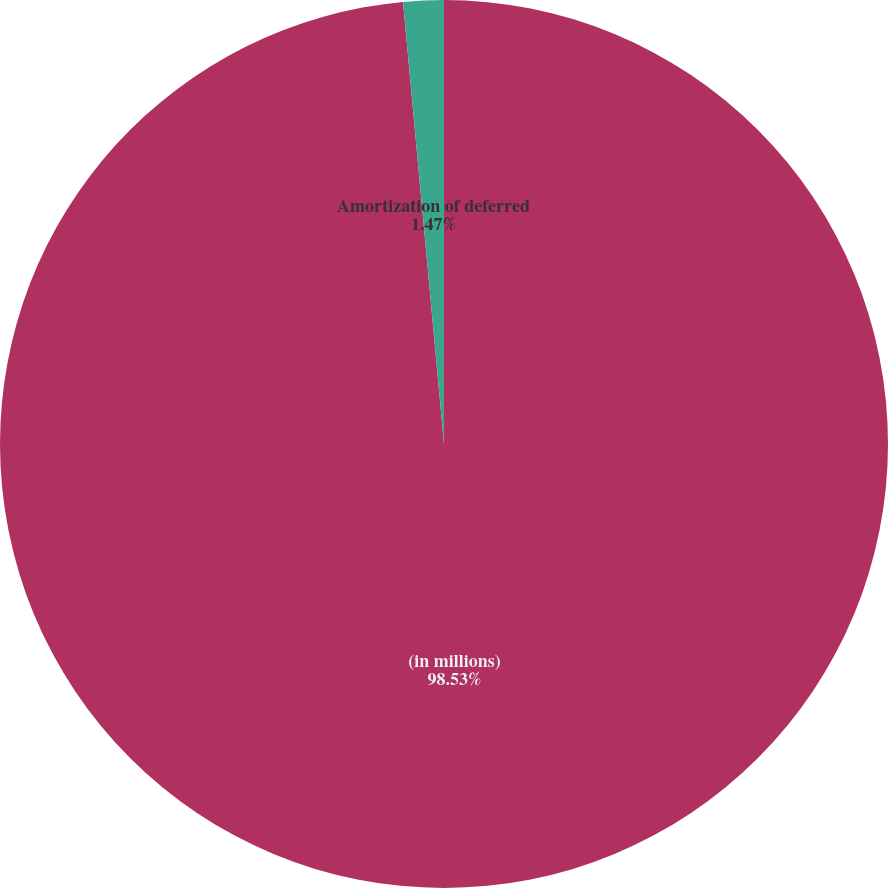<chart> <loc_0><loc_0><loc_500><loc_500><pie_chart><fcel>(in millions)<fcel>Amortization of deferred<nl><fcel>98.53%<fcel>1.47%<nl></chart> 